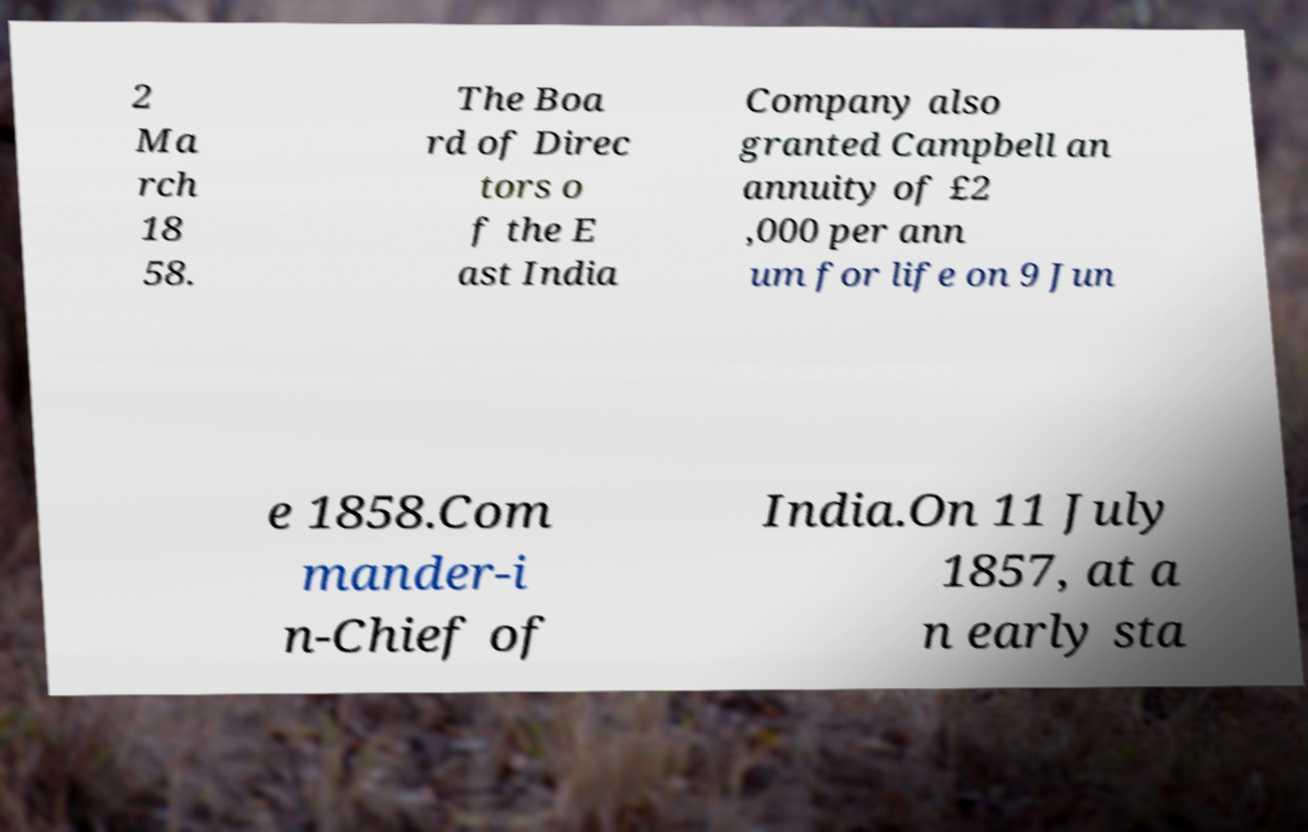Could you extract and type out the text from this image? 2 Ma rch 18 58. The Boa rd of Direc tors o f the E ast India Company also granted Campbell an annuity of £2 ,000 per ann um for life on 9 Jun e 1858.Com mander-i n-Chief of India.On 11 July 1857, at a n early sta 